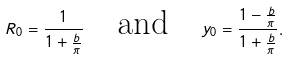Convert formula to latex. <formula><loc_0><loc_0><loc_500><loc_500>R _ { 0 } = \frac { 1 } { 1 + \frac { b } { \pi } } \quad \text {and} \quad y _ { 0 } = \frac { 1 - \frac { b } { \pi } } { 1 + \frac { b } { \pi } } .</formula> 